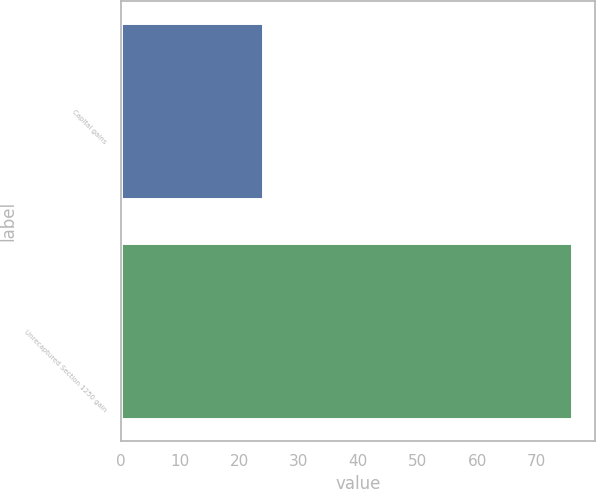Convert chart to OTSL. <chart><loc_0><loc_0><loc_500><loc_500><bar_chart><fcel>Capital gains<fcel>Unrecaptured Section 1250 gain<nl><fcel>24<fcel>76<nl></chart> 